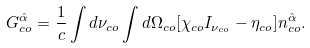<formula> <loc_0><loc_0><loc_500><loc_500>G _ { c o } ^ { \hat { \alpha } } = \frac { 1 } { c } \int d \nu _ { c o } \int d \Omega _ { c o } [ \chi _ { c o } I _ { \nu _ { c o } } - \eta _ { c o } ] n _ { c o } ^ { \hat { \alpha } } .</formula> 